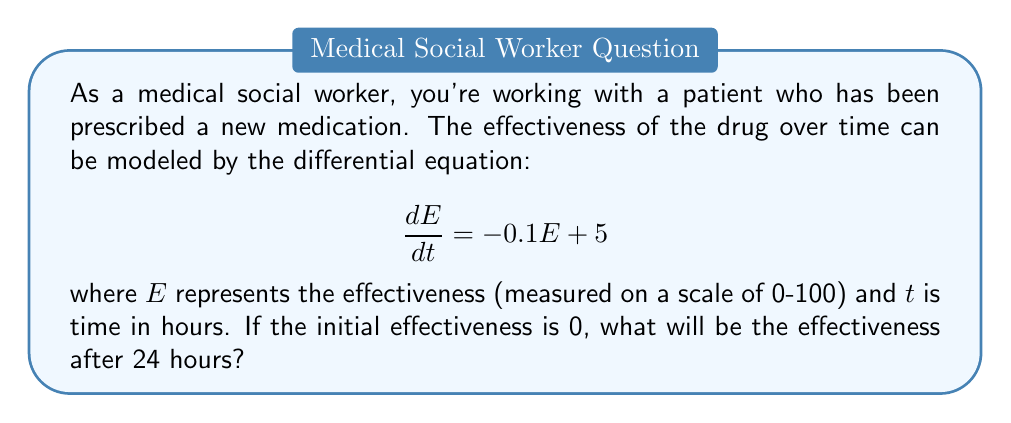Show me your answer to this math problem. To solve this problem, we need to follow these steps:

1) First, we recognize this as a first-order linear differential equation in the form:

   $$\frac{dE}{dt} + 0.1E = 5$$

2) The general solution for this type of equation is:

   $$E(t) = ce^{-0.1t} + 50$$

   where $c$ is a constant we need to determine.

3) We can find $c$ using the initial condition. At $t=0$, $E=0$:

   $$0 = c + 50$$
   $$c = -50$$

4) So our particular solution is:

   $$E(t) = -50e^{-0.1t} + 50$$

5) Now we can calculate the effectiveness at $t=24$:

   $$E(24) = -50e^{-0.1(24)} + 50$$
   $$= -50e^{-2.4} + 50$$
   $$\approx -4.53 + 50$$
   $$\approx 45.47$$

6) Rounding to two decimal places:

   $$E(24) \approx 45.47$$

This means after 24 hours, the effectiveness of the medication will be approximately 45.47 on a scale of 0-100.
Answer: 45.47 